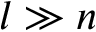Convert formula to latex. <formula><loc_0><loc_0><loc_500><loc_500>l \gg n</formula> 